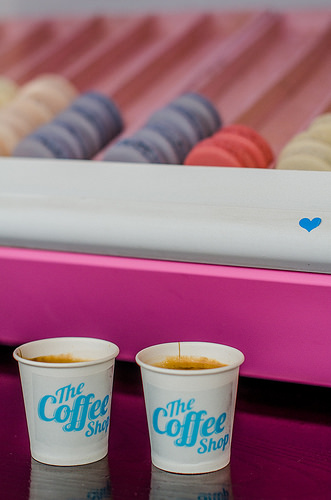<image>
Can you confirm if the cup is behind the wood? No. The cup is not behind the wood. From this viewpoint, the cup appears to be positioned elsewhere in the scene. Is there a coffee in front of the pastry? Yes. The coffee is positioned in front of the pastry, appearing closer to the camera viewpoint. 